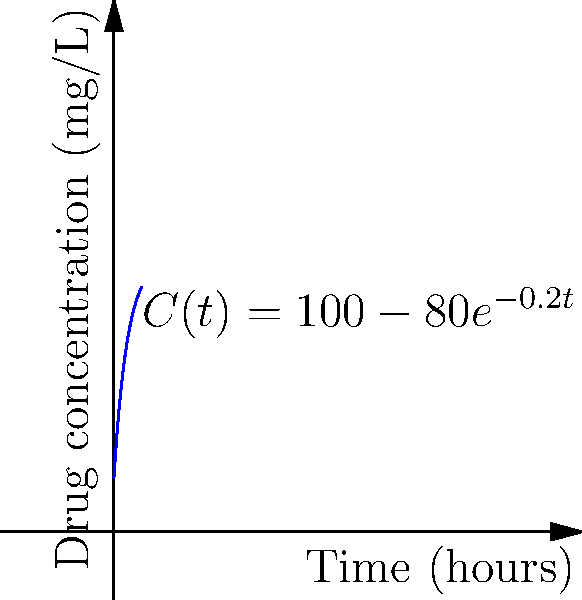A new antibiotic is administered intravenously to a patient. The concentration of the drug in the bloodstream over time is modeled by the function $C(t) = 100 - 80e^{-0.2t}$, where $C$ is the concentration in mg/L and $t$ is the time in hours. At what rate is the drug concentration changing after 5 hours? To find the rate of change of drug concentration after 5 hours, we need to follow these steps:

1) The rate of change is given by the derivative of the concentration function $C(t)$.

2) Let's find the derivative of $C(t)$:
   $C(t) = 100 - 80e^{-0.2t}$
   $C'(t) = 0 - 80 \cdot (-0.2) \cdot e^{-0.2t}$ (using the chain rule)
   $C'(t) = 16e^{-0.2t}$

3) Now, we need to evaluate $C'(t)$ at $t = 5$:
   $C'(5) = 16e^{-0.2(5)}$
   $C'(5) = 16e^{-1}$

4) Calculate this value:
   $C'(5) = 16 \cdot 0.3679 \approx 5.89$ mg/L/hour

Therefore, after 5 hours, the drug concentration is changing at a rate of approximately 5.89 mg/L per hour.
Answer: $5.89$ mg/L/hour 